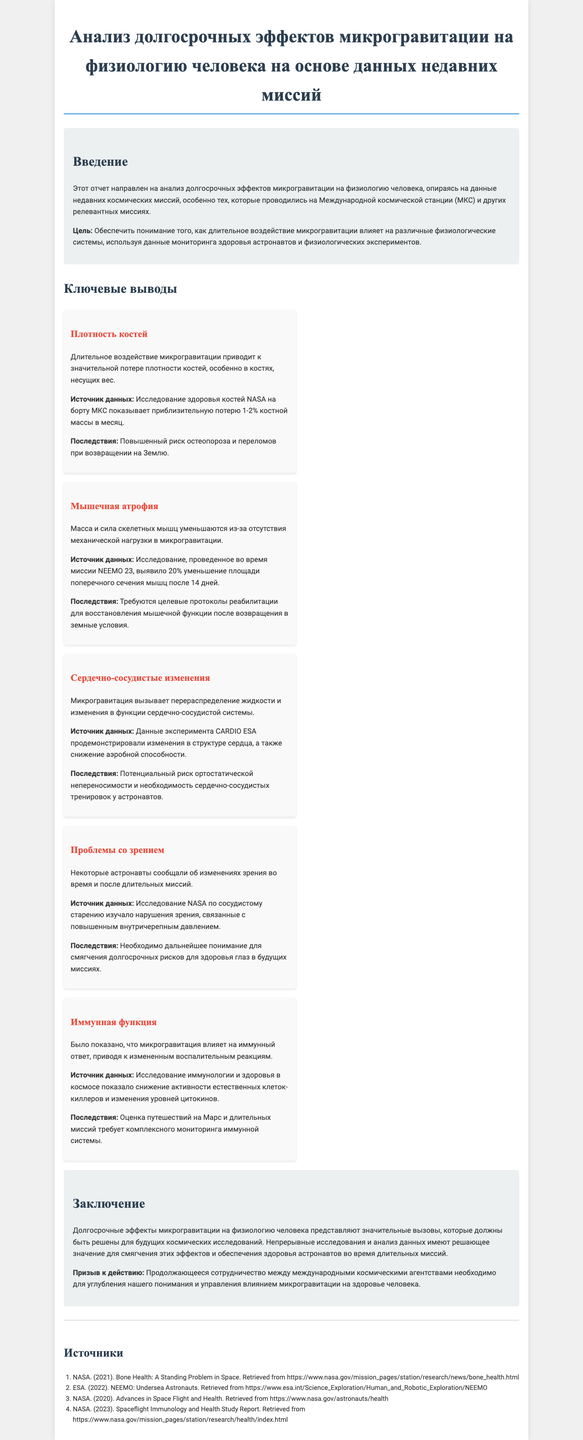what is the title of the report? The title of the report is clearly stated at the beginning of the document.
Answer: Анализ долгосрочных эффектов микрогравитации на физиологию человека на основе данных недавних миссий what is the main focus of the report? The report focuses on analyzing the long-term effects of microgravity on human physiology.
Answer: Долгосрочные эффекты микрогравитации на физиологию человека how much bone density is lost per month in microgravity? The document specifies the percentage of bone density loss observed monthly in astronauts during missions.
Answer: 1-2% what changes occur in skeletal muscle mass in microgravity? The report highlights the specific effects of microgravity on skeletal muscle mass due to lack of mechanical load.
Answer: Уменьшаются масса и сила скелетных мышц what cardiovascular issue is mentioned regarding microgravity? The document addresses a particular cardiovascular change caused by microgravity, focusing on one aspect of the heart's condition.
Answer: Изменения в функции сердечно-сосудистой системы what type of vision problems do astronauts experience in space? The report specifies a particular type of vision issue encountered by astronauts during their missions.
Answer: Изменения зрения what recommendation is made for future missions? The conclusion section suggests an action to enhance understanding of a specific issue related to human health in microgravity.
Answer: Продолжающееся сотрудничество между международными космическими агентствами what is the source of data for bone density analysis? The document provides a reference source for the study of bone health in astronauts, which includes the organization as well.
Answer: Исследование здоровья костей NASA 